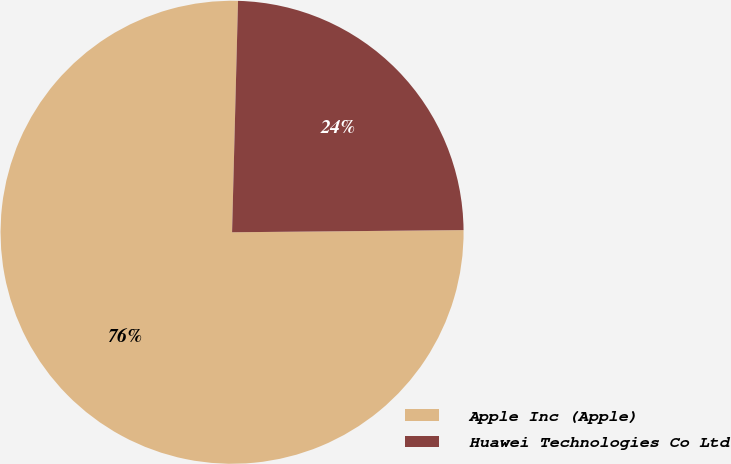<chart> <loc_0><loc_0><loc_500><loc_500><pie_chart><fcel>Apple Inc (Apple)<fcel>Huawei Technologies Co Ltd<nl><fcel>75.56%<fcel>24.44%<nl></chart> 